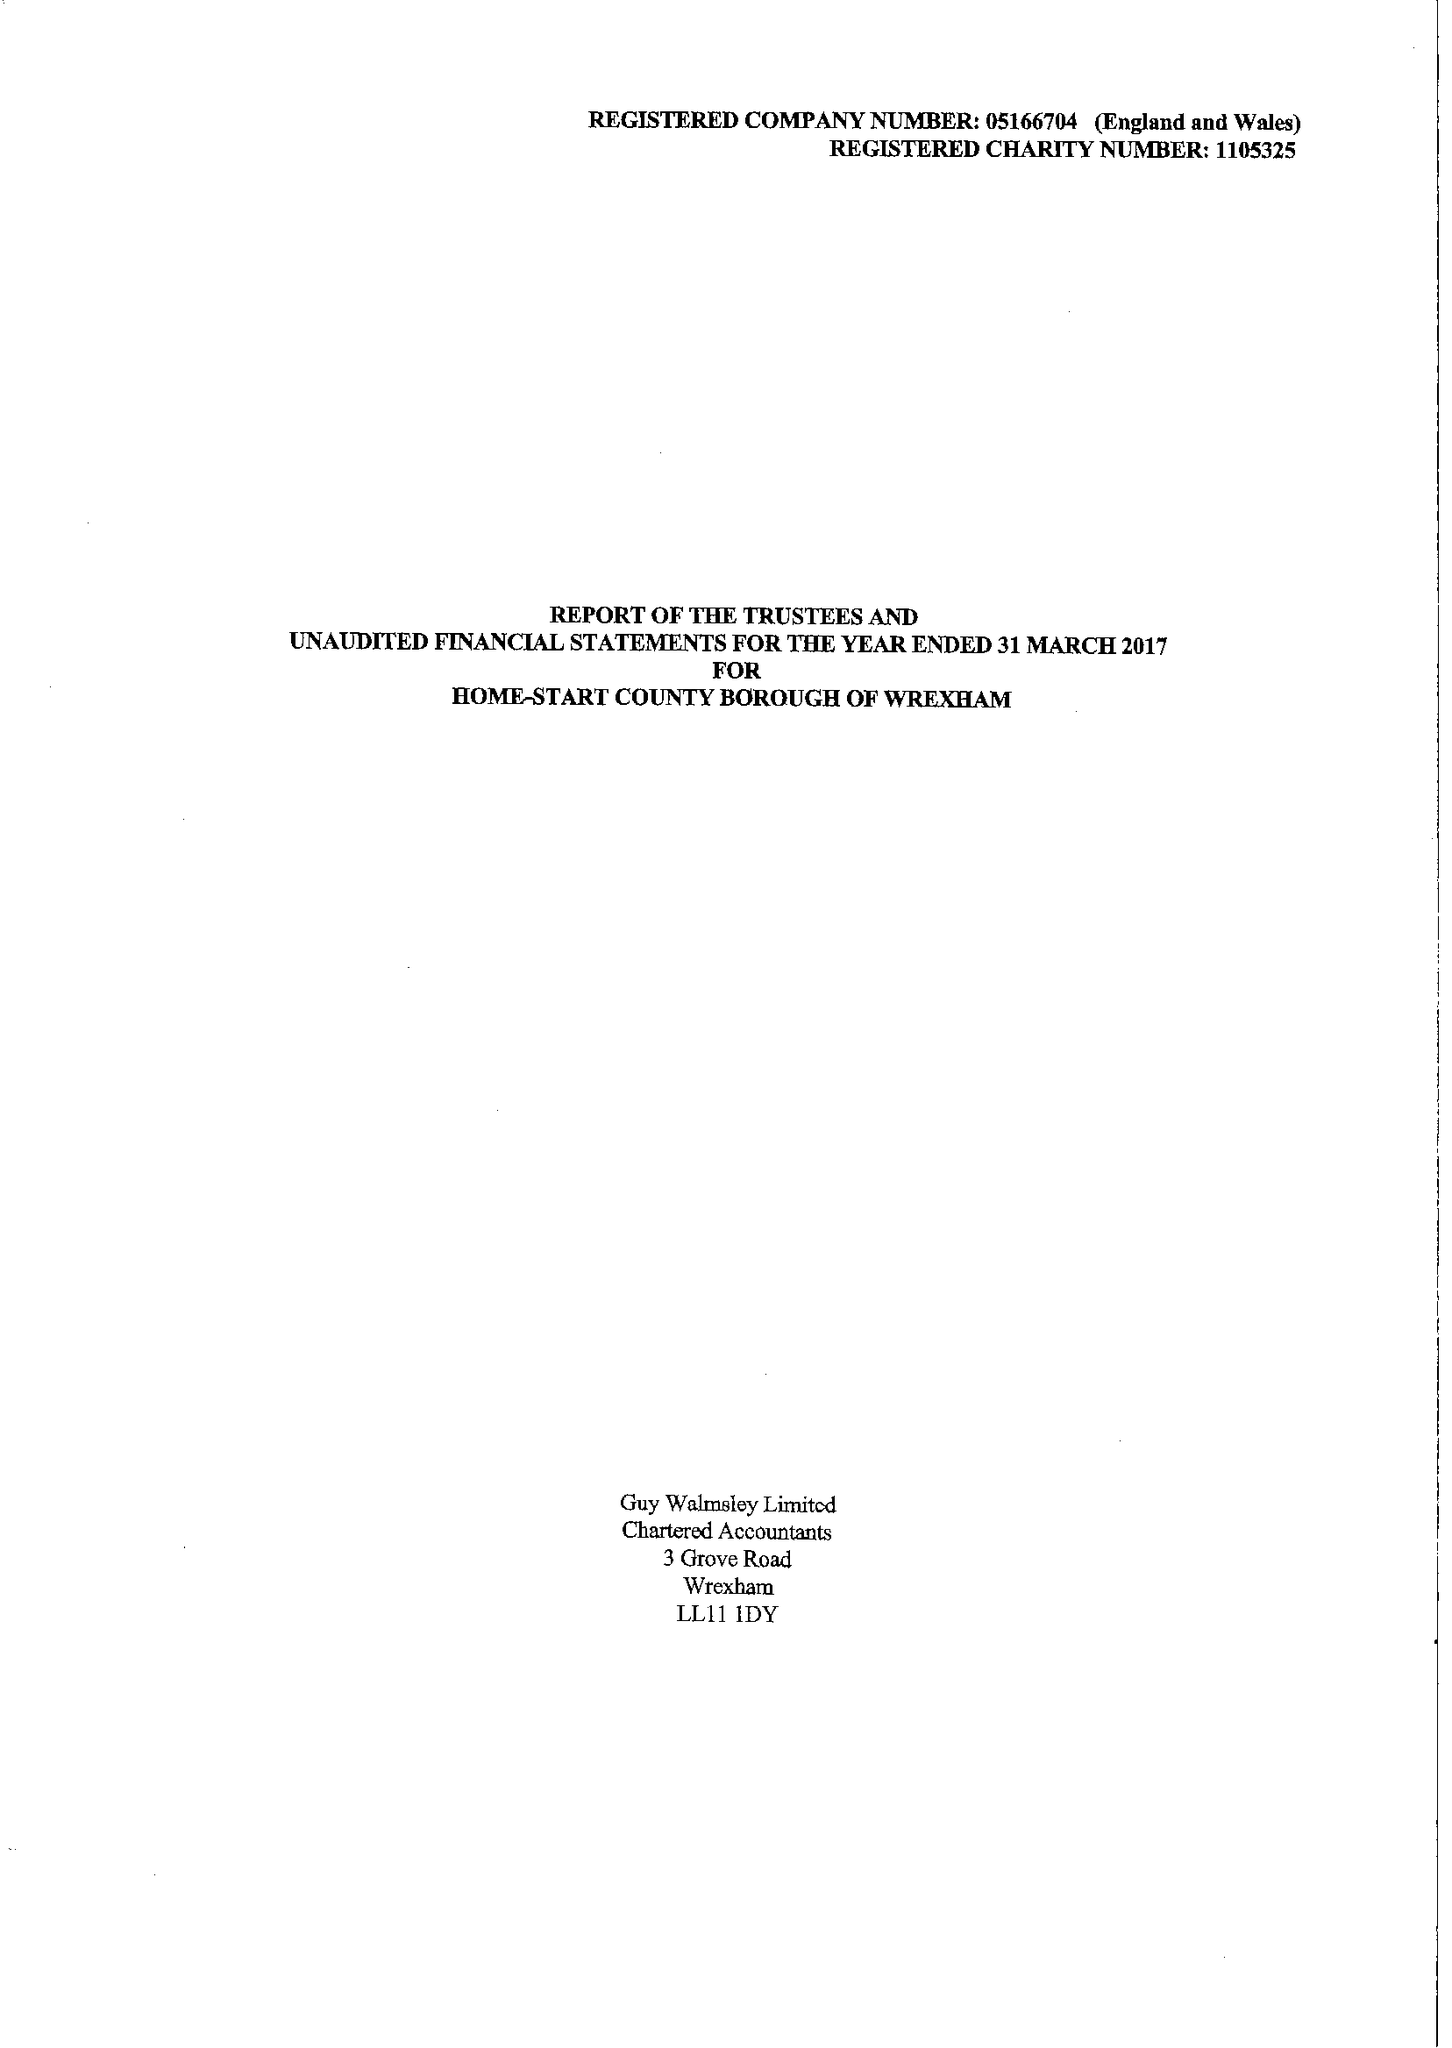What is the value for the charity_name?
Answer the question using a single word or phrase. Home-Start County Borough Of Wrexham 